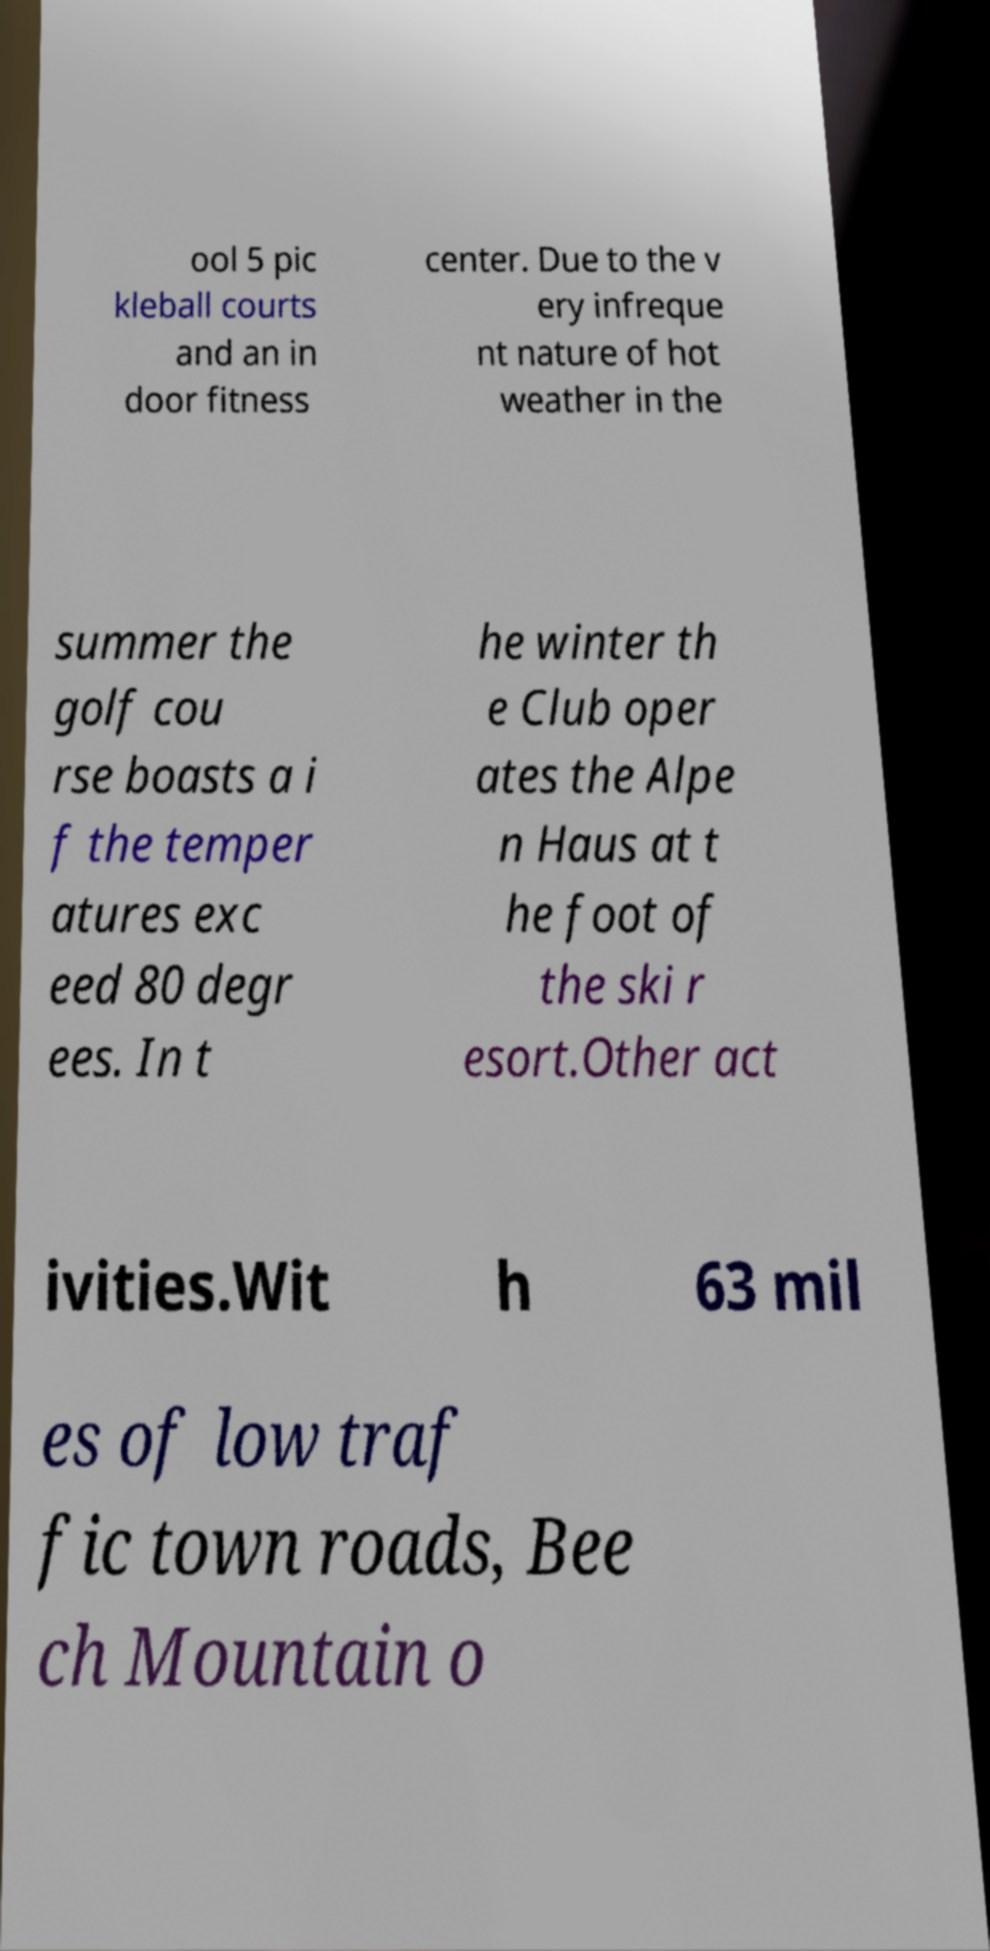Could you extract and type out the text from this image? ool 5 pic kleball courts and an in door fitness center. Due to the v ery infreque nt nature of hot weather in the summer the golf cou rse boasts a i f the temper atures exc eed 80 degr ees. In t he winter th e Club oper ates the Alpe n Haus at t he foot of the ski r esort.Other act ivities.Wit h 63 mil es of low traf fic town roads, Bee ch Mountain o 